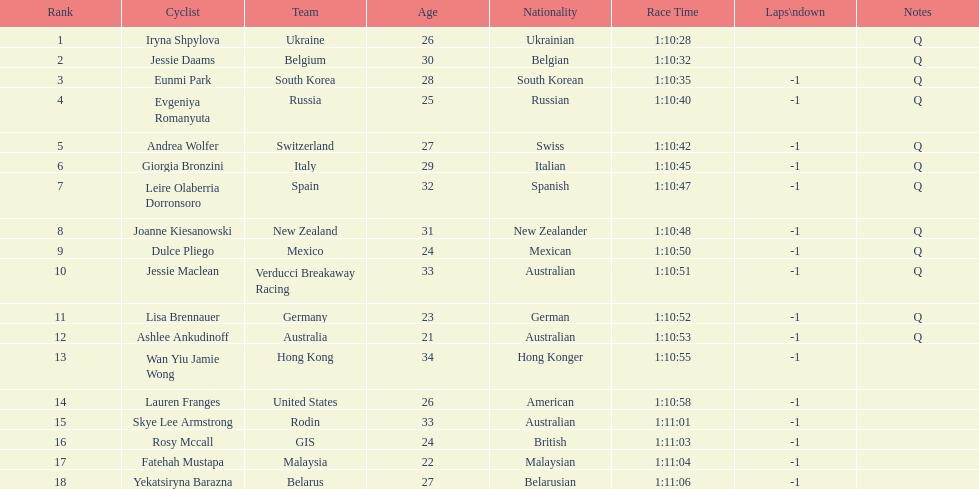Who was the top ranked competitor in this race? Iryna Shpylova. 